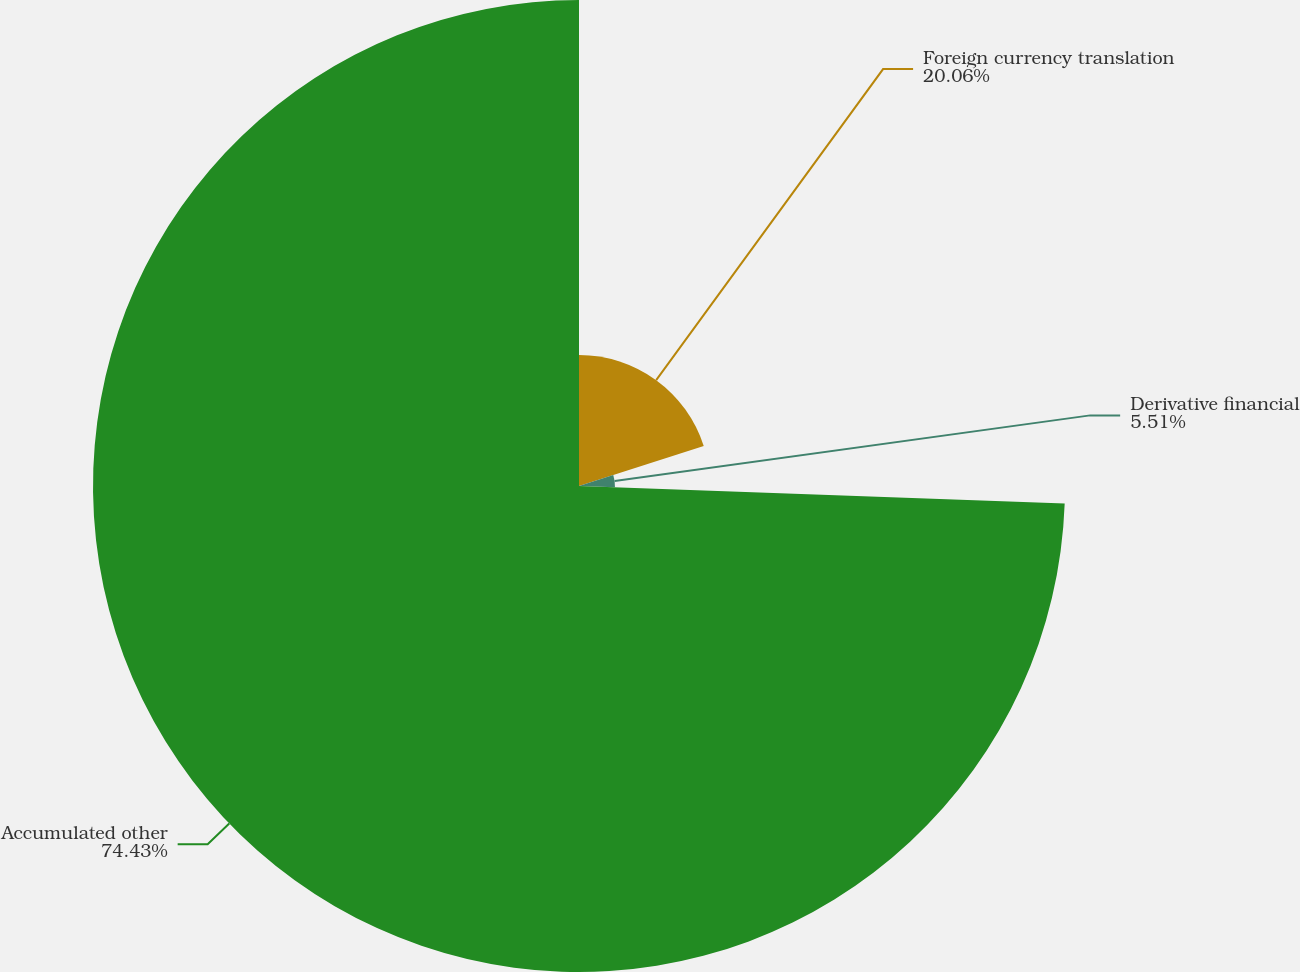<chart> <loc_0><loc_0><loc_500><loc_500><pie_chart><fcel>Foreign currency translation<fcel>Derivative financial<fcel>Accumulated other<nl><fcel>20.06%<fcel>5.51%<fcel>74.43%<nl></chart> 